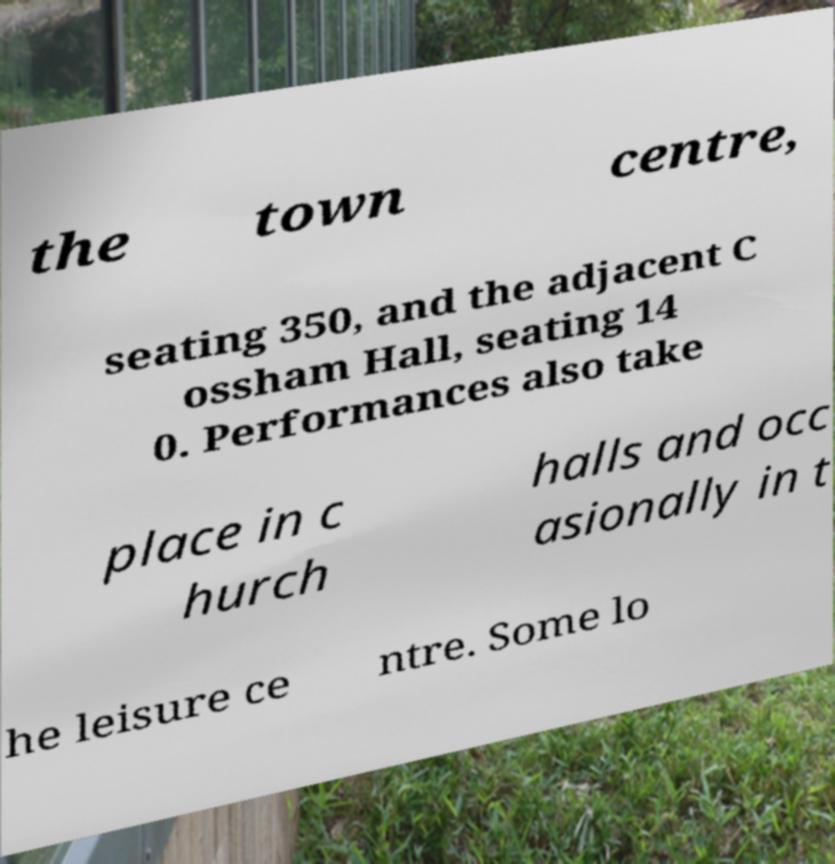I need the written content from this picture converted into text. Can you do that? the town centre, seating 350, and the adjacent C ossham Hall, seating 14 0. Performances also take place in c hurch halls and occ asionally in t he leisure ce ntre. Some lo 